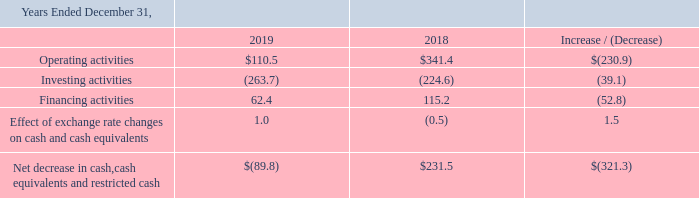Summary of Consolidated Cash Flows
The below table summarizes the cash provided or used in our activities and the amount of the respective changes between the periods (in millions):
Operating Activities Cash provided by operating activities was $110.5 million for the year ended December 31, 2019 as compared to cash provided by operating activities of $341.4 million for the year ended December 31, 2018. The $230.9 million decrease was the result of the recapture of reinsurance treaties by our Insurance segment in 2018 and was offset in part by improved performance of the Insurance segment subsequent to the KIC acquisition, significant reduction of losses at the Broadcasting segment driven by the cost cutting measures, and an increase in the working capital at our Telecommunications segments.
Investing Activities Cash used in investing activities was $263.7 million for the year ended December 31, 2019 as compared to cash used in investing activities of $224.6 million for the year ended December 31, 2018. The $39.1 million increase in cash used was a result of (i) an increase in net cash spent at our Insurance segment driven by purchases of investments from the residual cash received from the KIC acquisition and reinsurance recaptures in 2018, (ii) a decrease in cash proceeds received at our Life Sciences segment, from the 2018 upfront payment and 2019 escrow release related to the sale of BeneVir in the prior period, and (iii) an increase in cash used at our Energy segment to acquire ampCNG stations in 2019. These decreases were largely offset by a reduction in cash used by our Construction segment, driven by the acquisition of GrayWolf in 2018, and a reduction in cash used by our Broadcasting segment as less cash was used on its acquisitions in the current year compared to 2018.
This was largely offset by a reduction in net cash used by the Insurance segment's purchases of investments, as in the prior period the Insurance segment purchased investments from the cash received from the acquisition of KIC.
Financing Activities Cash provided by financing activities was $62.4 million for the year ended December 31, 2019 as compared to $115.2 million for the year ended December 31, 2018. The $52.8 million decrease was a result of a decrease in net borrowings by the Construction and Broadcasting segments, and offset in part by the increase in net borrowings by the Energy segment and Corporate segment, and a decline in cash paid to noncontrolling interest holders driven by the proceeds from our Life Sciences segment's sale of BeneVir in 2018.
What is the cash provided by operating activities in 2019? $110.5 million. What is the cash provided by financing activities in 2019? $62.4 million. What was the cash provided by investing activities in 2019?
Answer scale should be: million. (263.7). What is the percentage increase / (decrease) in the operating activities from 2018 to 2019?
Answer scale should be: percent. 110.5 / 341.4 - 1
Answer: -67.63. What is the average investing activities?
Answer scale should be: million. -(263.7 + 224.6) / 2
Answer: -244.15. What is the average financing activities?
Answer scale should be: million. (62.4 + 115.2) / 2
Answer: 88.8. 